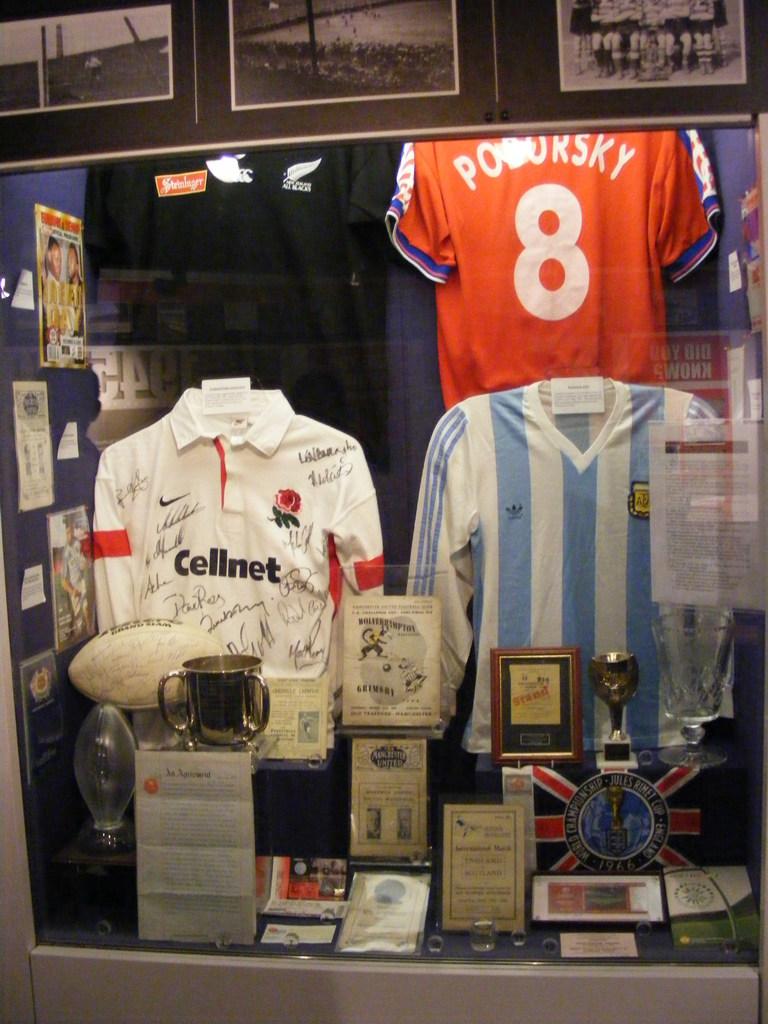What is the jersey number?
Make the answer very short. 8. 